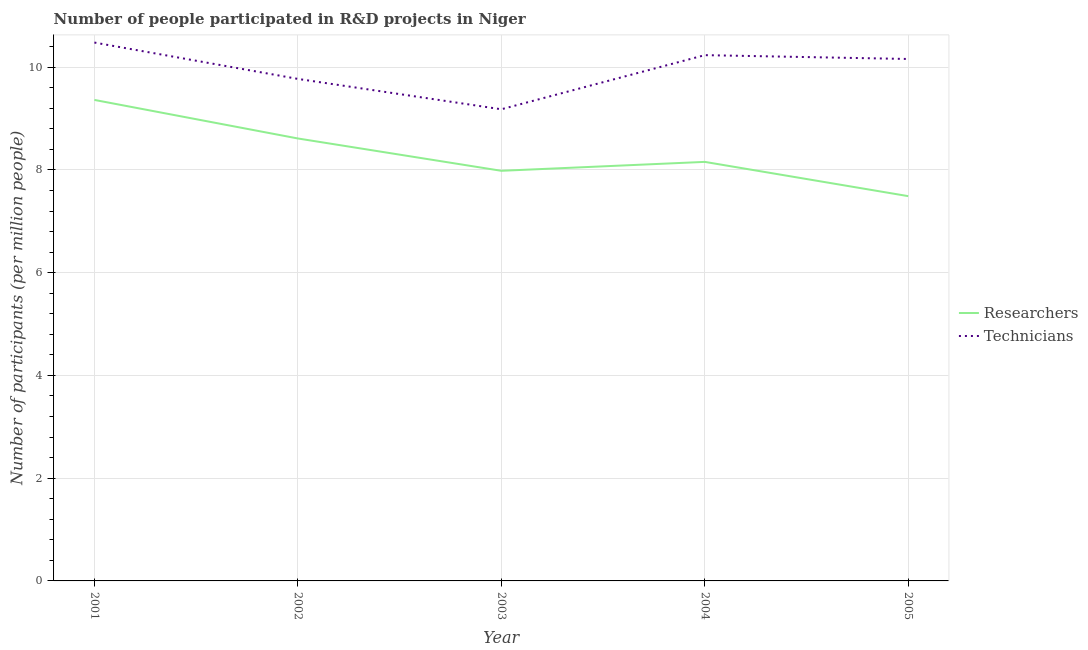Does the line corresponding to number of technicians intersect with the line corresponding to number of researchers?
Make the answer very short. No. Is the number of lines equal to the number of legend labels?
Provide a short and direct response. Yes. What is the number of researchers in 2005?
Your answer should be compact. 7.49. Across all years, what is the maximum number of researchers?
Your response must be concise. 9.36. Across all years, what is the minimum number of researchers?
Keep it short and to the point. 7.49. In which year was the number of researchers maximum?
Your response must be concise. 2001. In which year was the number of technicians minimum?
Provide a succinct answer. 2003. What is the total number of researchers in the graph?
Offer a terse response. 41.6. What is the difference between the number of researchers in 2001 and that in 2004?
Provide a succinct answer. 1.21. What is the difference between the number of technicians in 2002 and the number of researchers in 2005?
Give a very brief answer. 2.28. What is the average number of researchers per year?
Ensure brevity in your answer.  8.32. In the year 2004, what is the difference between the number of researchers and number of technicians?
Keep it short and to the point. -2.08. What is the ratio of the number of researchers in 2001 to that in 2004?
Offer a very short reply. 1.15. Is the difference between the number of researchers in 2001 and 2002 greater than the difference between the number of technicians in 2001 and 2002?
Keep it short and to the point. Yes. What is the difference between the highest and the second highest number of technicians?
Offer a terse response. 0.25. What is the difference between the highest and the lowest number of researchers?
Your answer should be very brief. 1.87. Does the number of researchers monotonically increase over the years?
Ensure brevity in your answer.  No. How many years are there in the graph?
Provide a short and direct response. 5. What is the difference between two consecutive major ticks on the Y-axis?
Make the answer very short. 2. How are the legend labels stacked?
Offer a terse response. Vertical. What is the title of the graph?
Ensure brevity in your answer.  Number of people participated in R&D projects in Niger. Does "Research and Development" appear as one of the legend labels in the graph?
Give a very brief answer. No. What is the label or title of the X-axis?
Make the answer very short. Year. What is the label or title of the Y-axis?
Your answer should be compact. Number of participants (per million people). What is the Number of participants (per million people) of Researchers in 2001?
Offer a terse response. 9.36. What is the Number of participants (per million people) in Technicians in 2001?
Offer a very short reply. 10.48. What is the Number of participants (per million people) of Researchers in 2002?
Keep it short and to the point. 8.61. What is the Number of participants (per million people) in Technicians in 2002?
Your answer should be compact. 9.77. What is the Number of participants (per million people) of Researchers in 2003?
Offer a very short reply. 7.98. What is the Number of participants (per million people) in Technicians in 2003?
Offer a terse response. 9.18. What is the Number of participants (per million people) of Researchers in 2004?
Your answer should be compact. 8.16. What is the Number of participants (per million people) in Technicians in 2004?
Your answer should be very brief. 10.23. What is the Number of participants (per million people) of Researchers in 2005?
Ensure brevity in your answer.  7.49. What is the Number of participants (per million people) of Technicians in 2005?
Keep it short and to the point. 10.16. Across all years, what is the maximum Number of participants (per million people) in Researchers?
Make the answer very short. 9.36. Across all years, what is the maximum Number of participants (per million people) of Technicians?
Offer a terse response. 10.48. Across all years, what is the minimum Number of participants (per million people) in Researchers?
Keep it short and to the point. 7.49. Across all years, what is the minimum Number of participants (per million people) in Technicians?
Make the answer very short. 9.18. What is the total Number of participants (per million people) of Researchers in the graph?
Make the answer very short. 41.6. What is the total Number of participants (per million people) in Technicians in the graph?
Ensure brevity in your answer.  49.82. What is the difference between the Number of participants (per million people) of Researchers in 2001 and that in 2002?
Your answer should be compact. 0.75. What is the difference between the Number of participants (per million people) in Technicians in 2001 and that in 2002?
Make the answer very short. 0.71. What is the difference between the Number of participants (per million people) of Researchers in 2001 and that in 2003?
Offer a very short reply. 1.38. What is the difference between the Number of participants (per million people) in Technicians in 2001 and that in 2003?
Your answer should be compact. 1.3. What is the difference between the Number of participants (per million people) of Researchers in 2001 and that in 2004?
Provide a succinct answer. 1.21. What is the difference between the Number of participants (per million people) of Technicians in 2001 and that in 2004?
Your answer should be very brief. 0.25. What is the difference between the Number of participants (per million people) of Researchers in 2001 and that in 2005?
Provide a succinct answer. 1.87. What is the difference between the Number of participants (per million people) of Technicians in 2001 and that in 2005?
Keep it short and to the point. 0.32. What is the difference between the Number of participants (per million people) of Researchers in 2002 and that in 2003?
Give a very brief answer. 0.63. What is the difference between the Number of participants (per million people) of Technicians in 2002 and that in 2003?
Provide a short and direct response. 0.59. What is the difference between the Number of participants (per million people) in Researchers in 2002 and that in 2004?
Your response must be concise. 0.46. What is the difference between the Number of participants (per million people) of Technicians in 2002 and that in 2004?
Your response must be concise. -0.46. What is the difference between the Number of participants (per million people) of Researchers in 2002 and that in 2005?
Provide a short and direct response. 1.12. What is the difference between the Number of participants (per million people) in Technicians in 2002 and that in 2005?
Provide a succinct answer. -0.39. What is the difference between the Number of participants (per million people) of Researchers in 2003 and that in 2004?
Your answer should be compact. -0.17. What is the difference between the Number of participants (per million people) in Technicians in 2003 and that in 2004?
Your response must be concise. -1.05. What is the difference between the Number of participants (per million people) in Researchers in 2003 and that in 2005?
Your answer should be very brief. 0.49. What is the difference between the Number of participants (per million people) of Technicians in 2003 and that in 2005?
Offer a terse response. -0.98. What is the difference between the Number of participants (per million people) of Researchers in 2004 and that in 2005?
Your answer should be compact. 0.67. What is the difference between the Number of participants (per million people) of Technicians in 2004 and that in 2005?
Keep it short and to the point. 0.07. What is the difference between the Number of participants (per million people) in Researchers in 2001 and the Number of participants (per million people) in Technicians in 2002?
Your response must be concise. -0.41. What is the difference between the Number of participants (per million people) of Researchers in 2001 and the Number of participants (per million people) of Technicians in 2003?
Offer a very short reply. 0.18. What is the difference between the Number of participants (per million people) in Researchers in 2001 and the Number of participants (per million people) in Technicians in 2004?
Your response must be concise. -0.87. What is the difference between the Number of participants (per million people) of Researchers in 2001 and the Number of participants (per million people) of Technicians in 2005?
Ensure brevity in your answer.  -0.8. What is the difference between the Number of participants (per million people) of Researchers in 2002 and the Number of participants (per million people) of Technicians in 2003?
Provide a succinct answer. -0.57. What is the difference between the Number of participants (per million people) of Researchers in 2002 and the Number of participants (per million people) of Technicians in 2004?
Give a very brief answer. -1.62. What is the difference between the Number of participants (per million people) of Researchers in 2002 and the Number of participants (per million people) of Technicians in 2005?
Your answer should be very brief. -1.55. What is the difference between the Number of participants (per million people) of Researchers in 2003 and the Number of participants (per million people) of Technicians in 2004?
Offer a very short reply. -2.25. What is the difference between the Number of participants (per million people) of Researchers in 2003 and the Number of participants (per million people) of Technicians in 2005?
Your answer should be very brief. -2.18. What is the difference between the Number of participants (per million people) of Researchers in 2004 and the Number of participants (per million people) of Technicians in 2005?
Your response must be concise. -2. What is the average Number of participants (per million people) in Researchers per year?
Your answer should be compact. 8.32. What is the average Number of participants (per million people) in Technicians per year?
Your answer should be compact. 9.96. In the year 2001, what is the difference between the Number of participants (per million people) of Researchers and Number of participants (per million people) of Technicians?
Offer a terse response. -1.12. In the year 2002, what is the difference between the Number of participants (per million people) of Researchers and Number of participants (per million people) of Technicians?
Offer a terse response. -1.16. In the year 2003, what is the difference between the Number of participants (per million people) of Researchers and Number of participants (per million people) of Technicians?
Your response must be concise. -1.2. In the year 2004, what is the difference between the Number of participants (per million people) of Researchers and Number of participants (per million people) of Technicians?
Your answer should be compact. -2.08. In the year 2005, what is the difference between the Number of participants (per million people) of Researchers and Number of participants (per million people) of Technicians?
Your answer should be compact. -2.67. What is the ratio of the Number of participants (per million people) of Researchers in 2001 to that in 2002?
Ensure brevity in your answer.  1.09. What is the ratio of the Number of participants (per million people) of Technicians in 2001 to that in 2002?
Give a very brief answer. 1.07. What is the ratio of the Number of participants (per million people) in Researchers in 2001 to that in 2003?
Ensure brevity in your answer.  1.17. What is the ratio of the Number of participants (per million people) in Technicians in 2001 to that in 2003?
Provide a succinct answer. 1.14. What is the ratio of the Number of participants (per million people) in Researchers in 2001 to that in 2004?
Keep it short and to the point. 1.15. What is the ratio of the Number of participants (per million people) of Researchers in 2001 to that in 2005?
Provide a succinct answer. 1.25. What is the ratio of the Number of participants (per million people) of Technicians in 2001 to that in 2005?
Provide a succinct answer. 1.03. What is the ratio of the Number of participants (per million people) of Researchers in 2002 to that in 2003?
Your answer should be compact. 1.08. What is the ratio of the Number of participants (per million people) of Technicians in 2002 to that in 2003?
Give a very brief answer. 1.06. What is the ratio of the Number of participants (per million people) of Researchers in 2002 to that in 2004?
Make the answer very short. 1.06. What is the ratio of the Number of participants (per million people) in Technicians in 2002 to that in 2004?
Your answer should be very brief. 0.95. What is the ratio of the Number of participants (per million people) of Researchers in 2002 to that in 2005?
Provide a succinct answer. 1.15. What is the ratio of the Number of participants (per million people) of Technicians in 2002 to that in 2005?
Your answer should be compact. 0.96. What is the ratio of the Number of participants (per million people) of Researchers in 2003 to that in 2004?
Offer a terse response. 0.98. What is the ratio of the Number of participants (per million people) of Technicians in 2003 to that in 2004?
Offer a very short reply. 0.9. What is the ratio of the Number of participants (per million people) in Researchers in 2003 to that in 2005?
Offer a very short reply. 1.07. What is the ratio of the Number of participants (per million people) of Technicians in 2003 to that in 2005?
Make the answer very short. 0.9. What is the ratio of the Number of participants (per million people) in Researchers in 2004 to that in 2005?
Provide a succinct answer. 1.09. What is the ratio of the Number of participants (per million people) of Technicians in 2004 to that in 2005?
Give a very brief answer. 1.01. What is the difference between the highest and the second highest Number of participants (per million people) of Researchers?
Make the answer very short. 0.75. What is the difference between the highest and the second highest Number of participants (per million people) in Technicians?
Offer a terse response. 0.25. What is the difference between the highest and the lowest Number of participants (per million people) in Researchers?
Your answer should be compact. 1.87. What is the difference between the highest and the lowest Number of participants (per million people) of Technicians?
Offer a very short reply. 1.3. 